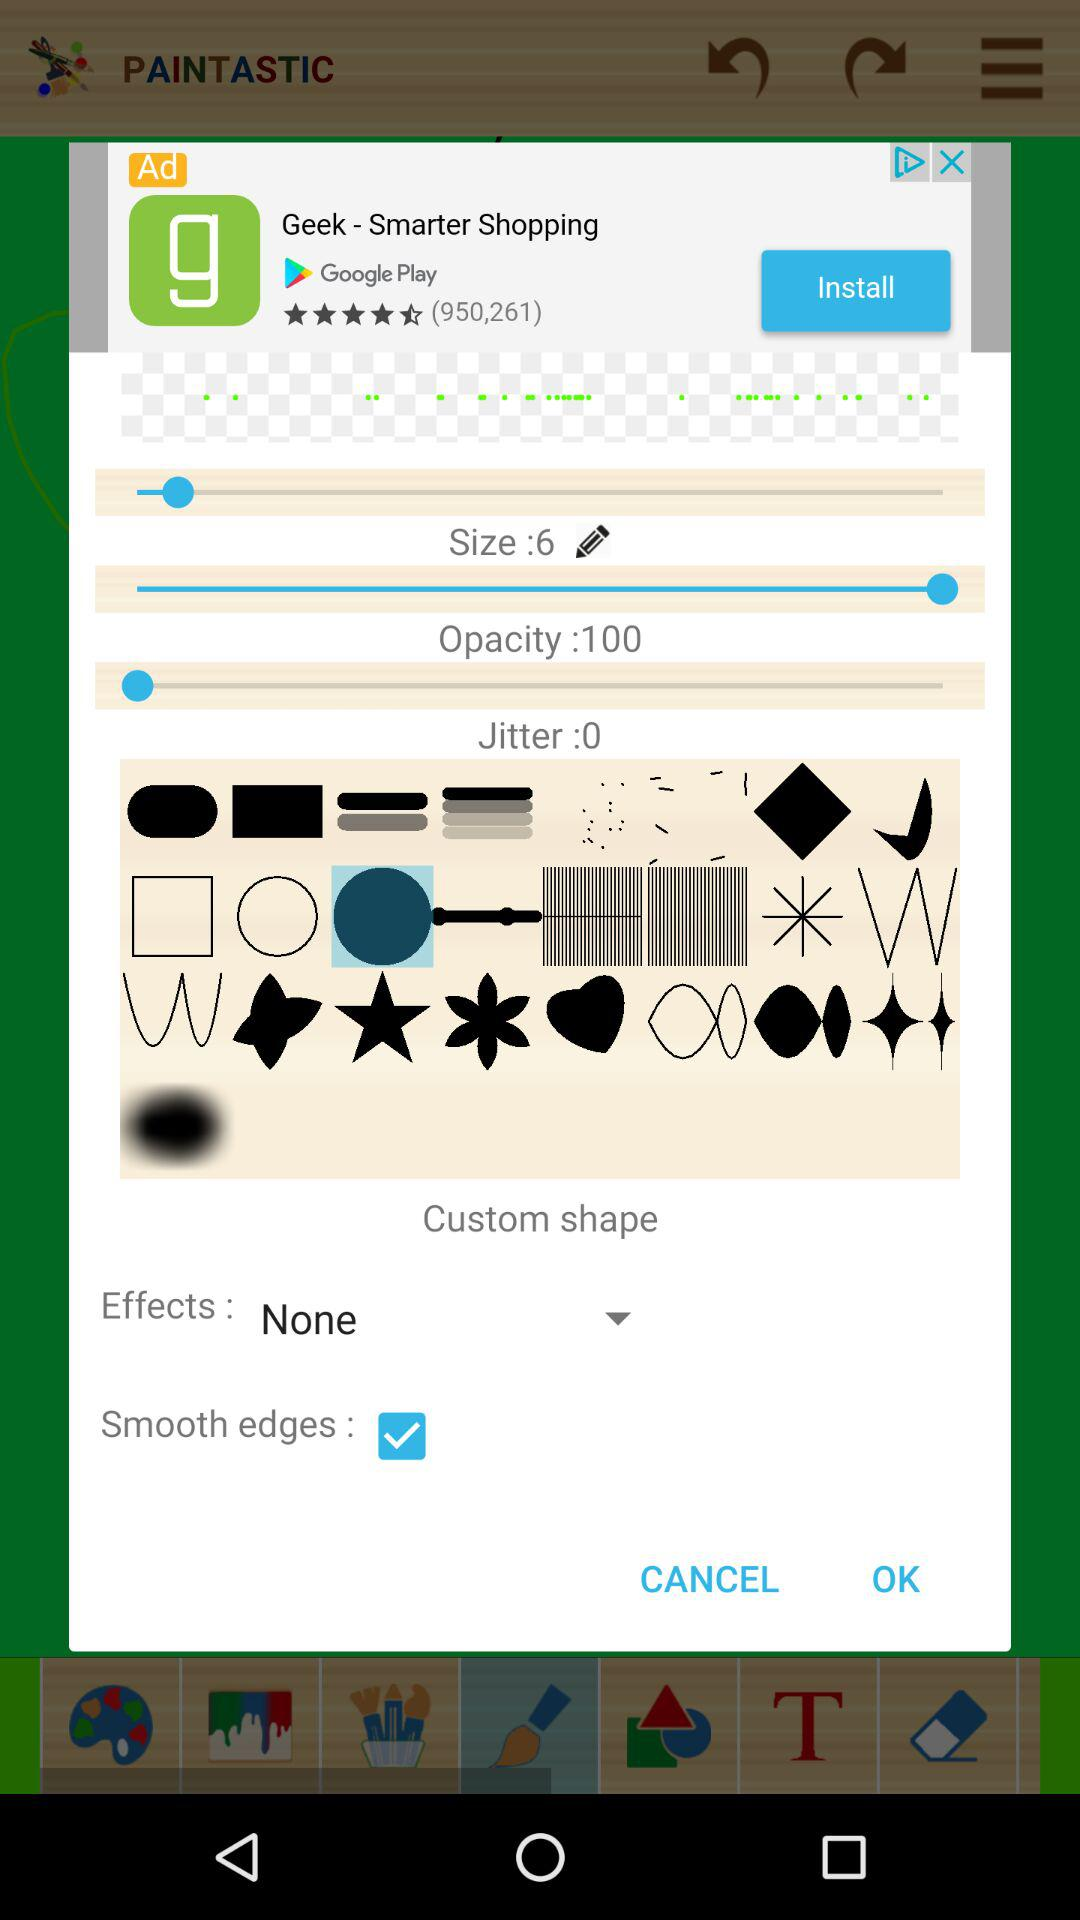What is the size? The size is 6. 